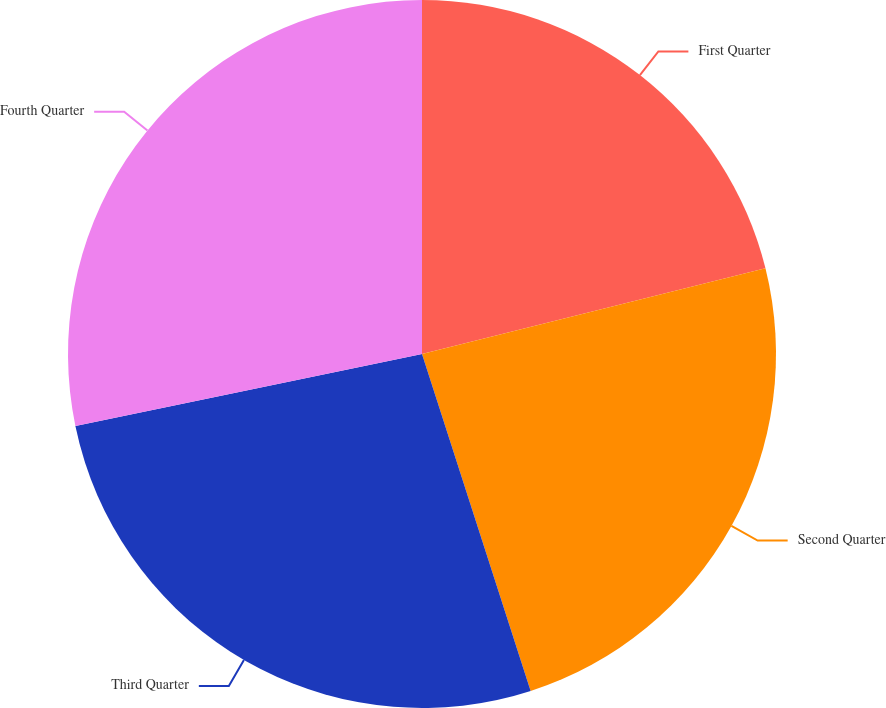Convert chart. <chart><loc_0><loc_0><loc_500><loc_500><pie_chart><fcel>First Quarter<fcel>Second Quarter<fcel>Third Quarter<fcel>Fourth Quarter<nl><fcel>21.11%<fcel>23.93%<fcel>26.71%<fcel>28.26%<nl></chart> 